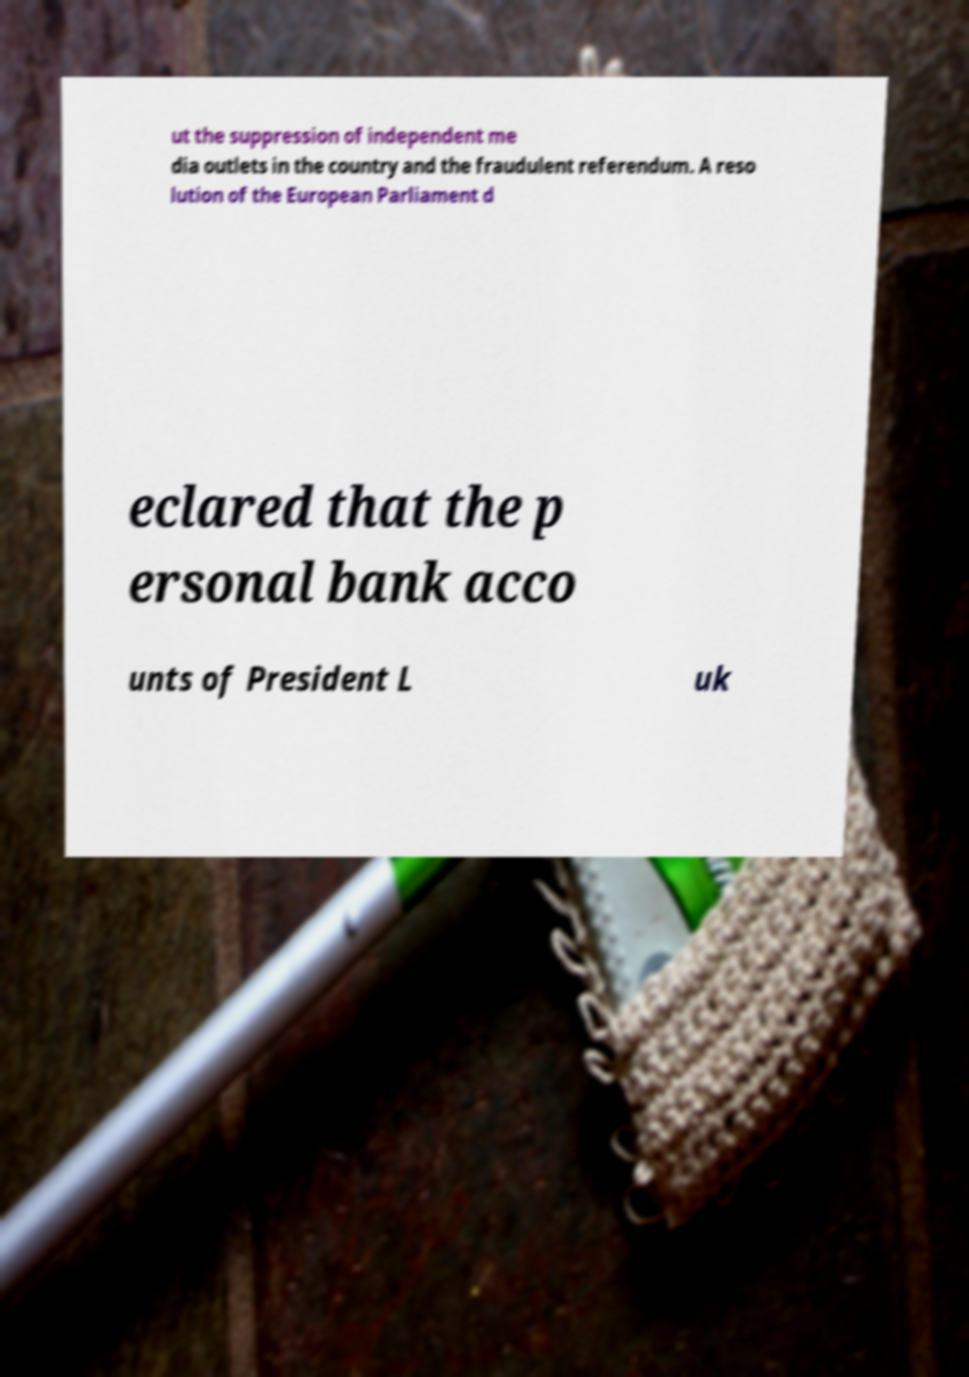Can you read and provide the text displayed in the image?This photo seems to have some interesting text. Can you extract and type it out for me? ut the suppression of independent me dia outlets in the country and the fraudulent referendum. A reso lution of the European Parliament d eclared that the p ersonal bank acco unts of President L uk 